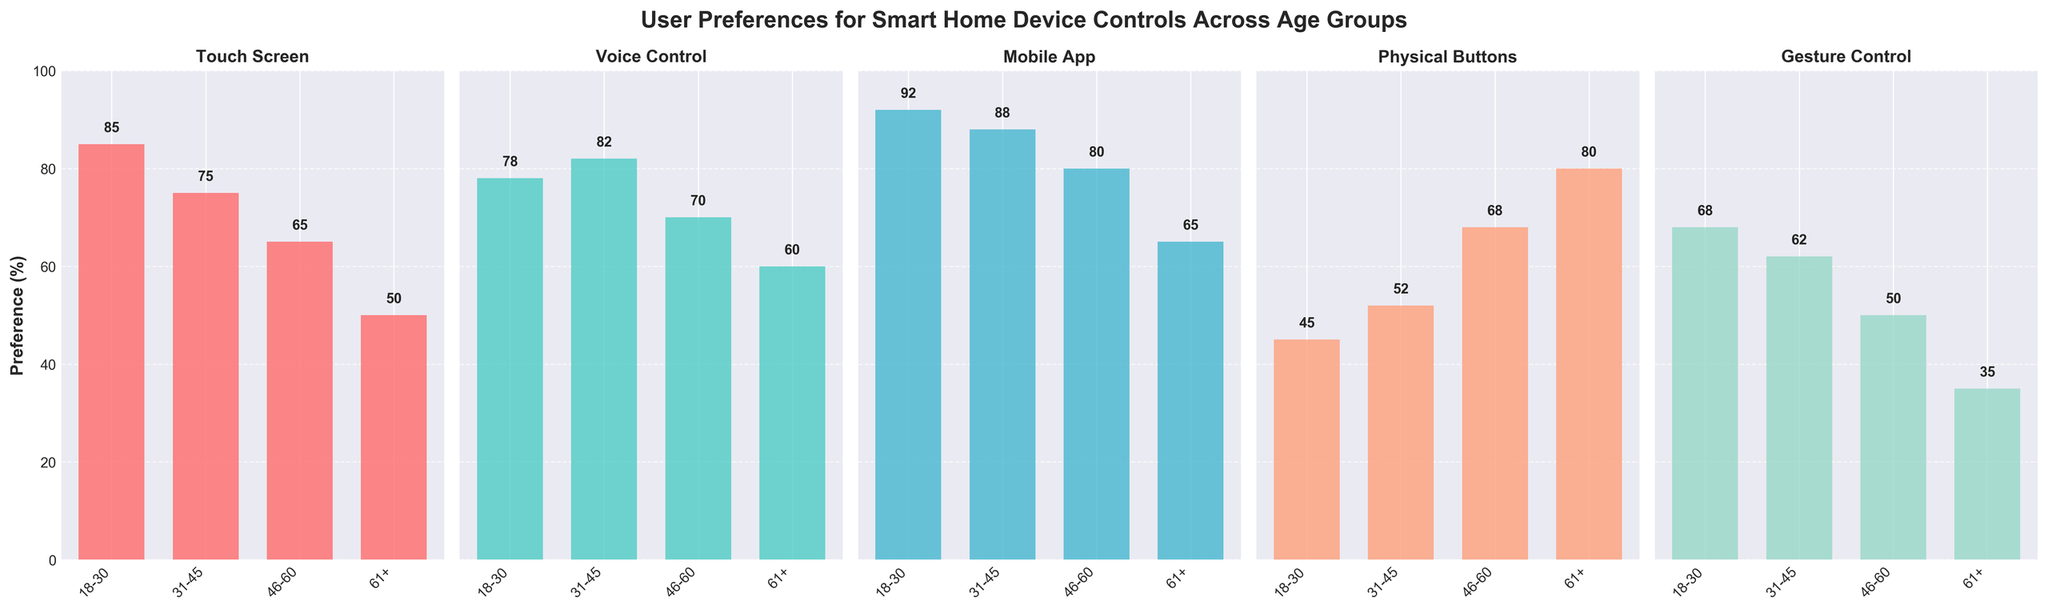What control type is most preferred by the 18-30 age group? The tallest bar in the subplot for the 18-30 age group indicates their highest preference. For the 18-30 age group, Mobile App has the highest bar, standing at 92.
Answer: Mobile App Which age group has the lowest preference for Gesture Control? The height of the bars for Gesture Control across all age groups shows the values 68, 62, 50, and 35. The 61+ age group has the shortest bar, indicating the lowest preference.
Answer: 61+ What is the difference in preference for Physical Buttons between the 18-30 and 61+ age groups? The bar heights for Physical Buttons in the 18-30 and 61+ subplots are 45 and 80, respectively. The difference is calculated as 80 - 45.
Answer: 35 Which control type has the smallest difference in preference between the 18-30 and 31-45 age groups? Subtract the preference values of 18-30 and 31-45 for each control type: Touch Screen (85-75=10), Voice Control (78-82=-4), Mobile App (92-88=4), Physical Buttons (45-52=-7), Gesture Control (68-62=6). The smallest difference is observed in Voice Control with a difference of -4.
Answer: Voice Control What is the average preference percentage for the age group 46-60 across all control types? Add the values for 46-60 across all control types (65 + 70 + 80 + 68 + 50) and divide by the number of control types (5). The sum is 333, so the average is 333/5.
Answer: 66.6 Which control type shows a decreasing trend in preference as age increases? Examine the bars for each control type across all age groups. For Touch Screen: 85, 75, 65, 50; for Voice Control: 78, 82, 70, 60; for Mobile App: 92, 88, 80, 65; for Physical Buttons: 45, 52, 68, 80; for Gesture Control: 68, 62, 50, 35. Touch Screen and Mobile App show a decreasing trend.
Answer: Touch Screen, Mobile App Which control type's preference increases from the 18-30 to 61+ age group? Check the bars for each control type across age groups. Physical Buttons show an increasing trend: 45, 52, 68, 80.
Answer: Physical Buttons Compare the preference for Voice Control between the 31-45 and 46-60 age groups. Which group prefers it more? Examine the heights of the Voice Control bars for these age groups. For 31-45: 82 and for 46-60: 70. The 31-45 age group has a higher preference.
Answer: 31-45 What is the sum of preferences for Gesture Control for all age groups? Add the values for Gesture Control across all age groups: 68 + 62 + 50 + 35. The sum is 215.
Answer: 215 